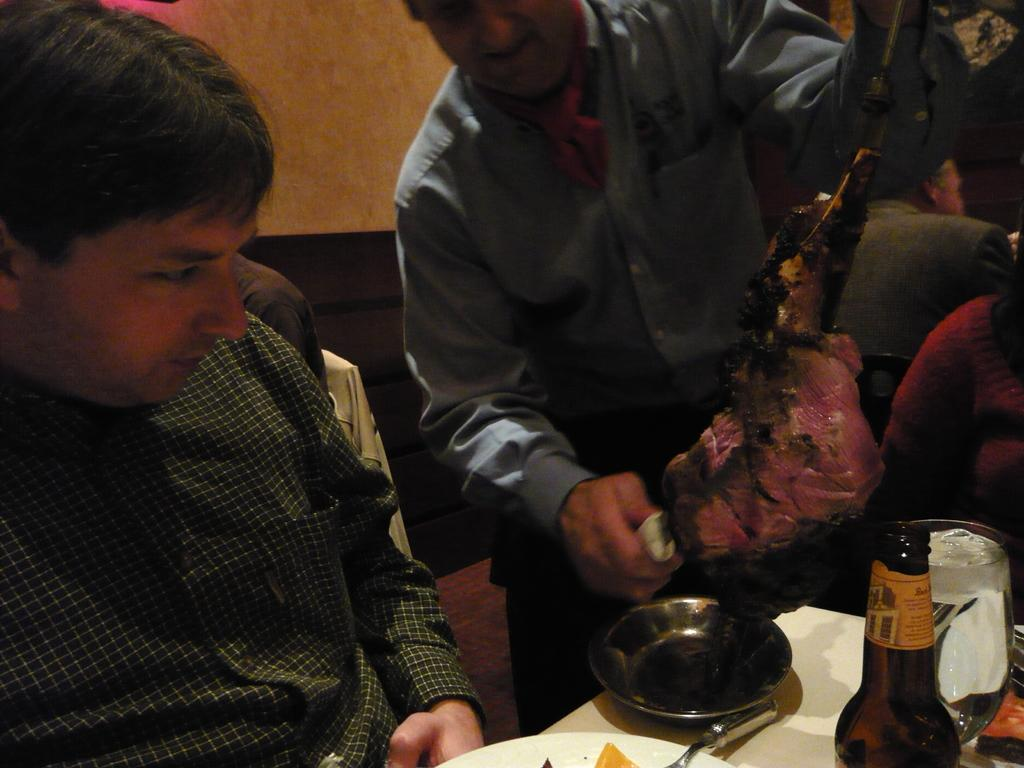How many men are in the image? There are two men in the image. What are the men doing in the image? The men are sitting and putting fire on a lamb. What can be seen related to drinks in the image? There is a wine bottle and a glass in the image. Can you see a seashore in the image? No, there is no seashore present in the image. How many dimes are visible on the table in the image? There are no dimes visible in the image. What type of container is used to hold arrows in the image? There is no container for holding arrows, such as a quiver, present in the image. 